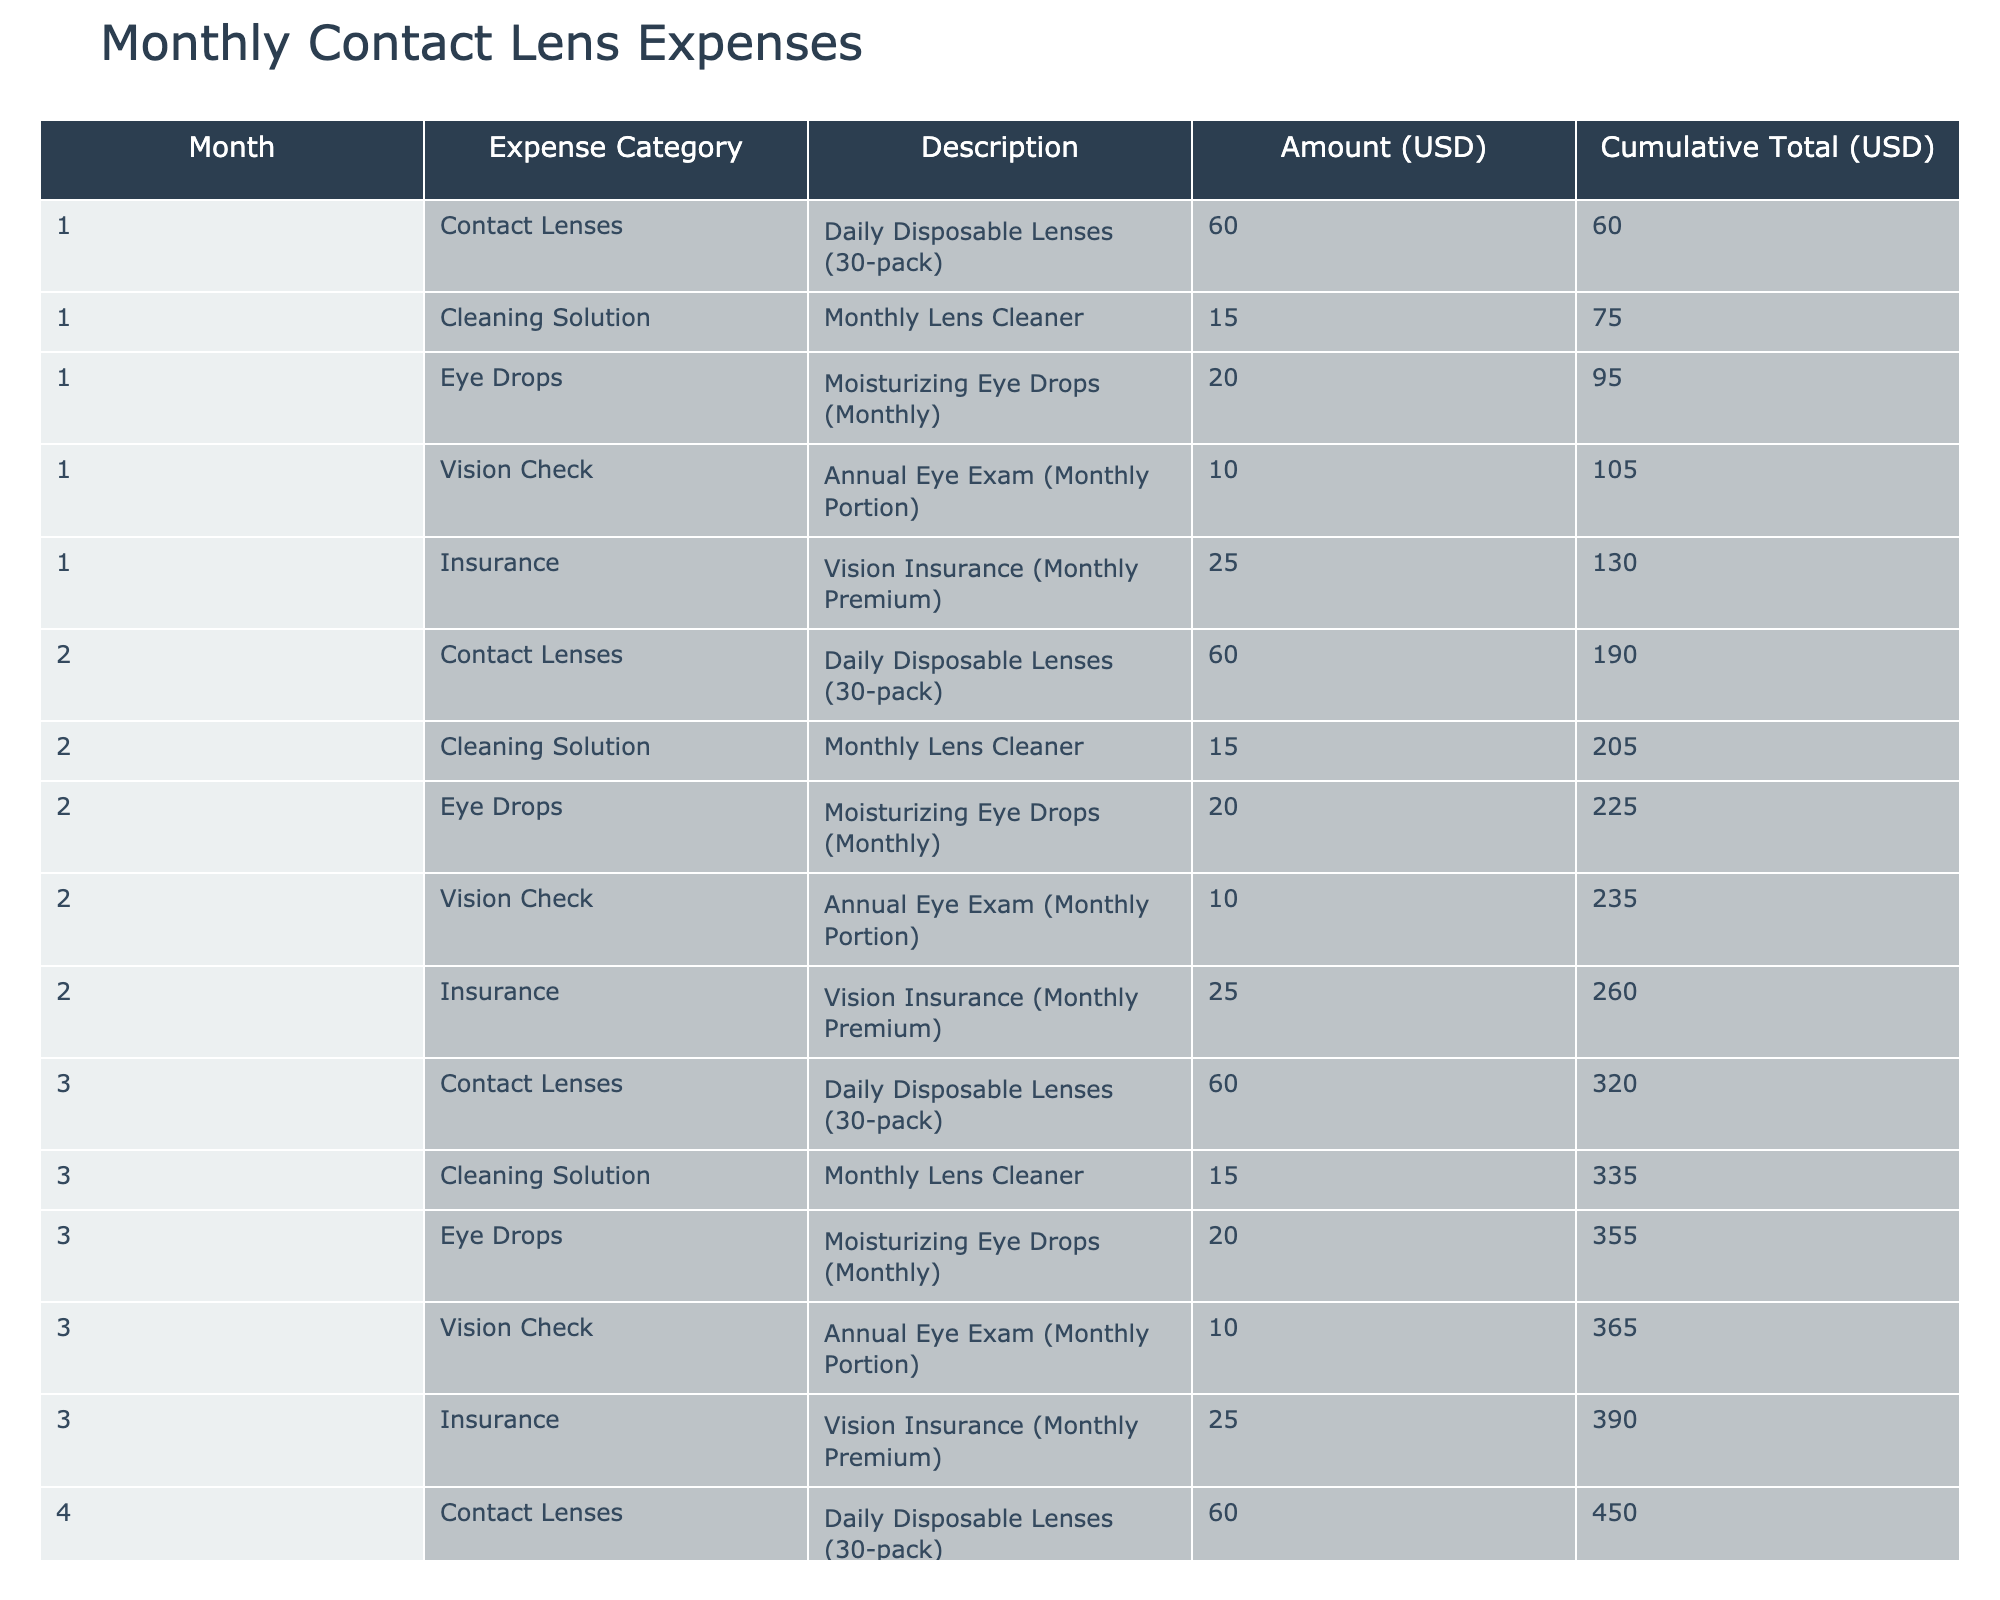What is the total amount spent on eye drops in the first three months? In the first three months, the eye drops cost $20 each month. Therefore, the total spent on eye drops is calculated as 3 months * $20 = $60.
Answer: 60 What was the cumulative total expense after the second month? In the second month, the cumulative total is reported as $260 in the table. This value is the sum of all expenses for the first two months.
Answer: 260 Did the expense on cleaning solutions remain constant across the six months? Yes, the cleaning solution expense is consistently $15 every month, as shown in the table for each of the six months.
Answer: Yes What is the average monthly expense for contact lenses over six months? The contact lenses are consistently $60 each month for six months, leading to a total of 6 months * $60 = $360. The average monthly expense is calculated by dividing by 6, $360 / 6 = $60.
Answer: 60 Which month had the highest cumulative total expense? The cumulative total expense increases steadily each month. By the end of the sixth month, it reaches $780, which is the highest cumulative total expense recorded in the table.
Answer: 780 How much did I spend on vision checks over the six months? Each month, the vision check expense is $10. Over six months, the total expense amounts to 6 months * $10 = $60 for vision checks.
Answer: 60 Is the expense on insurance more than the total spent on cleaning solutions after three months? The total spent on insurance after three months is 3 months * $25 = $75. The total for cleaning solutions after three months is 3 months * $15 = $45. Since $75 > $45, the answer is yes.
Answer: Yes What were the total expenses for cleaning solutions in the first month compared to the last month? The table shows that cleaning solution expense in the first month is $15 and in the last month is also $15. Since both values are equal, total expenses for cleaning solutions in both months are the same.
Answer: Equal 